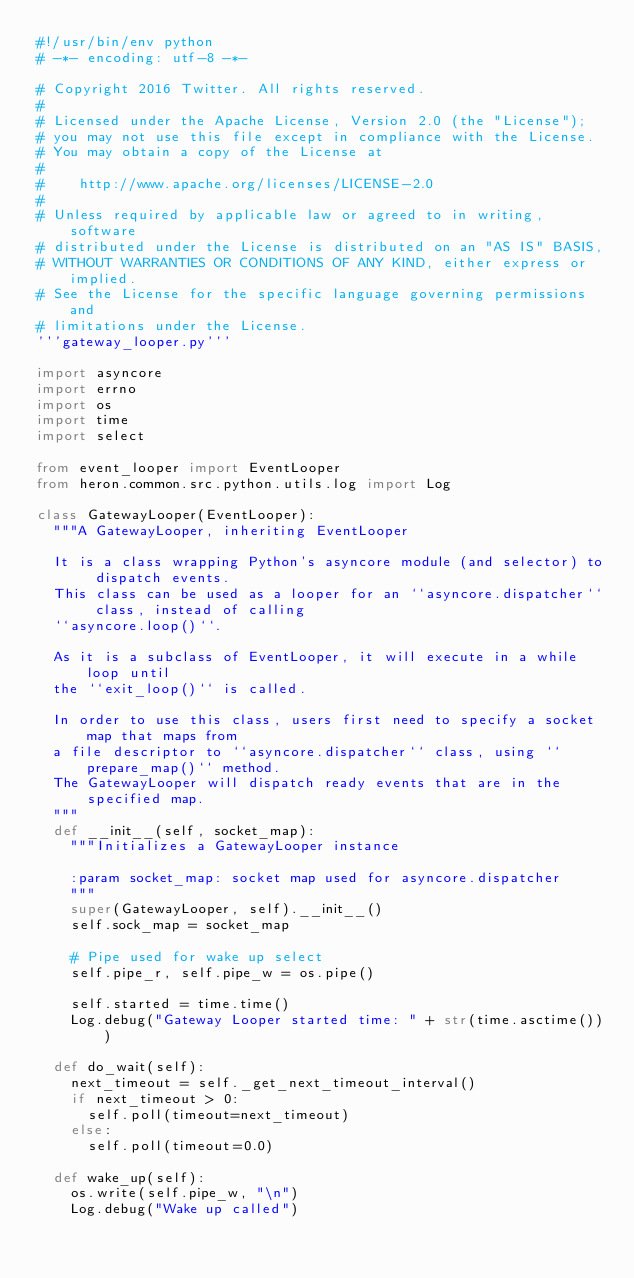Convert code to text. <code><loc_0><loc_0><loc_500><loc_500><_Python_>#!/usr/bin/env python
# -*- encoding: utf-8 -*-

# Copyright 2016 Twitter. All rights reserved.
#
# Licensed under the Apache License, Version 2.0 (the "License");
# you may not use this file except in compliance with the License.
# You may obtain a copy of the License at
#
#    http://www.apache.org/licenses/LICENSE-2.0
#
# Unless required by applicable law or agreed to in writing, software
# distributed under the License is distributed on an "AS IS" BASIS,
# WITHOUT WARRANTIES OR CONDITIONS OF ANY KIND, either express or implied.
# See the License for the specific language governing permissions and
# limitations under the License.
'''gateway_looper.py'''

import asyncore
import errno
import os
import time
import select

from event_looper import EventLooper
from heron.common.src.python.utils.log import Log

class GatewayLooper(EventLooper):
  """A GatewayLooper, inheriting EventLooper

  It is a class wrapping Python's asyncore module (and selector) to dispatch events.
  This class can be used as a looper for an ``asyncore.dispatcher`` class, instead of calling
  ``asyncore.loop()``.

  As it is a subclass of EventLooper, it will execute in a while loop until
  the ``exit_loop()`` is called.

  In order to use this class, users first need to specify a socket map that maps from
  a file descriptor to ``asyncore.dispatcher`` class, using ``prepare_map()`` method.
  The GatewayLooper will dispatch ready events that are in the specified map.
  """
  def __init__(self, socket_map):
    """Initializes a GatewayLooper instance

    :param socket_map: socket map used for asyncore.dispatcher
    """
    super(GatewayLooper, self).__init__()
    self.sock_map = socket_map

    # Pipe used for wake up select
    self.pipe_r, self.pipe_w = os.pipe()

    self.started = time.time()
    Log.debug("Gateway Looper started time: " + str(time.asctime()))

  def do_wait(self):
    next_timeout = self._get_next_timeout_interval()
    if next_timeout > 0:
      self.poll(timeout=next_timeout)
    else:
      self.poll(timeout=0.0)

  def wake_up(self):
    os.write(self.pipe_w, "\n")
    Log.debug("Wake up called")
</code> 